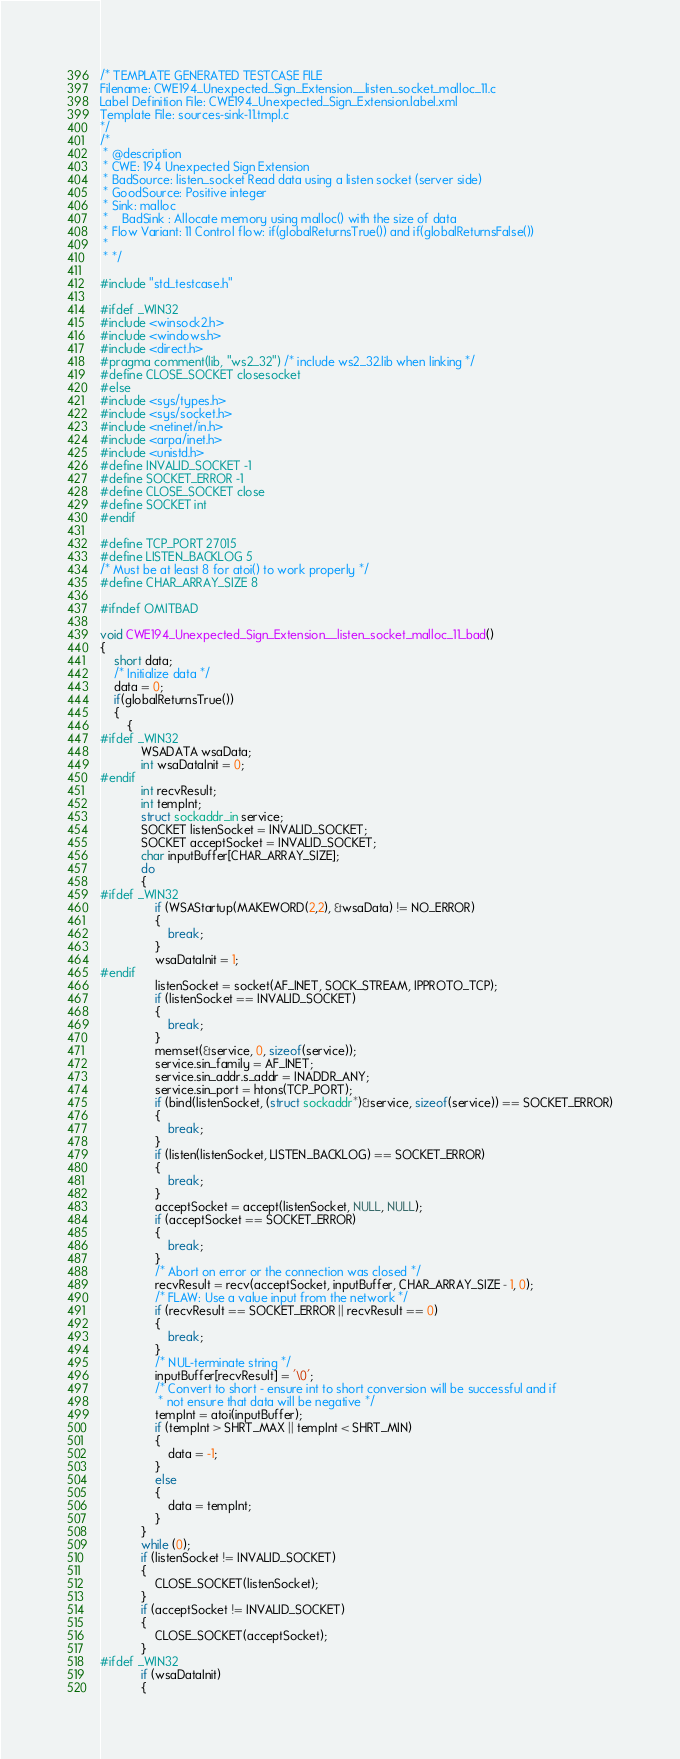<code> <loc_0><loc_0><loc_500><loc_500><_C_>/* TEMPLATE GENERATED TESTCASE FILE
Filename: CWE194_Unexpected_Sign_Extension__listen_socket_malloc_11.c
Label Definition File: CWE194_Unexpected_Sign_Extension.label.xml
Template File: sources-sink-11.tmpl.c
*/
/*
 * @description
 * CWE: 194 Unexpected Sign Extension
 * BadSource: listen_socket Read data using a listen socket (server side)
 * GoodSource: Positive integer
 * Sink: malloc
 *    BadSink : Allocate memory using malloc() with the size of data
 * Flow Variant: 11 Control flow: if(globalReturnsTrue()) and if(globalReturnsFalse())
 *
 * */

#include "std_testcase.h"

#ifdef _WIN32
#include <winsock2.h>
#include <windows.h>
#include <direct.h>
#pragma comment(lib, "ws2_32") /* include ws2_32.lib when linking */
#define CLOSE_SOCKET closesocket
#else
#include <sys/types.h>
#include <sys/socket.h>
#include <netinet/in.h>
#include <arpa/inet.h>
#include <unistd.h>
#define INVALID_SOCKET -1
#define SOCKET_ERROR -1
#define CLOSE_SOCKET close
#define SOCKET int
#endif

#define TCP_PORT 27015
#define LISTEN_BACKLOG 5
/* Must be at least 8 for atoi() to work properly */
#define CHAR_ARRAY_SIZE 8

#ifndef OMITBAD

void CWE194_Unexpected_Sign_Extension__listen_socket_malloc_11_bad()
{
    short data;
    /* Initialize data */
    data = 0;
    if(globalReturnsTrue())
    {
        {
#ifdef _WIN32
            WSADATA wsaData;
            int wsaDataInit = 0;
#endif
            int recvResult;
            int tempInt;
            struct sockaddr_in service;
            SOCKET listenSocket = INVALID_SOCKET;
            SOCKET acceptSocket = INVALID_SOCKET;
            char inputBuffer[CHAR_ARRAY_SIZE];
            do
            {
#ifdef _WIN32
                if (WSAStartup(MAKEWORD(2,2), &wsaData) != NO_ERROR)
                {
                    break;
                }
                wsaDataInit = 1;
#endif
                listenSocket = socket(AF_INET, SOCK_STREAM, IPPROTO_TCP);
                if (listenSocket == INVALID_SOCKET)
                {
                    break;
                }
                memset(&service, 0, sizeof(service));
                service.sin_family = AF_INET;
                service.sin_addr.s_addr = INADDR_ANY;
                service.sin_port = htons(TCP_PORT);
                if (bind(listenSocket, (struct sockaddr*)&service, sizeof(service)) == SOCKET_ERROR)
                {
                    break;
                }
                if (listen(listenSocket, LISTEN_BACKLOG) == SOCKET_ERROR)
                {
                    break;
                }
                acceptSocket = accept(listenSocket, NULL, NULL);
                if (acceptSocket == SOCKET_ERROR)
                {
                    break;
                }
                /* Abort on error or the connection was closed */
                recvResult = recv(acceptSocket, inputBuffer, CHAR_ARRAY_SIZE - 1, 0);
                /* FLAW: Use a value input from the network */
                if (recvResult == SOCKET_ERROR || recvResult == 0)
                {
                    break;
                }
                /* NUL-terminate string */
                inputBuffer[recvResult] = '\0';
                /* Convert to short - ensure int to short conversion will be successful and if
                 * not ensure that data will be negative */
                tempInt = atoi(inputBuffer);
                if (tempInt > SHRT_MAX || tempInt < SHRT_MIN)
                {
                    data = -1;
                }
                else
                {
                    data = tempInt;
                }
            }
            while (0);
            if (listenSocket != INVALID_SOCKET)
            {
                CLOSE_SOCKET(listenSocket);
            }
            if (acceptSocket != INVALID_SOCKET)
            {
                CLOSE_SOCKET(acceptSocket);
            }
#ifdef _WIN32
            if (wsaDataInit)
            {</code> 